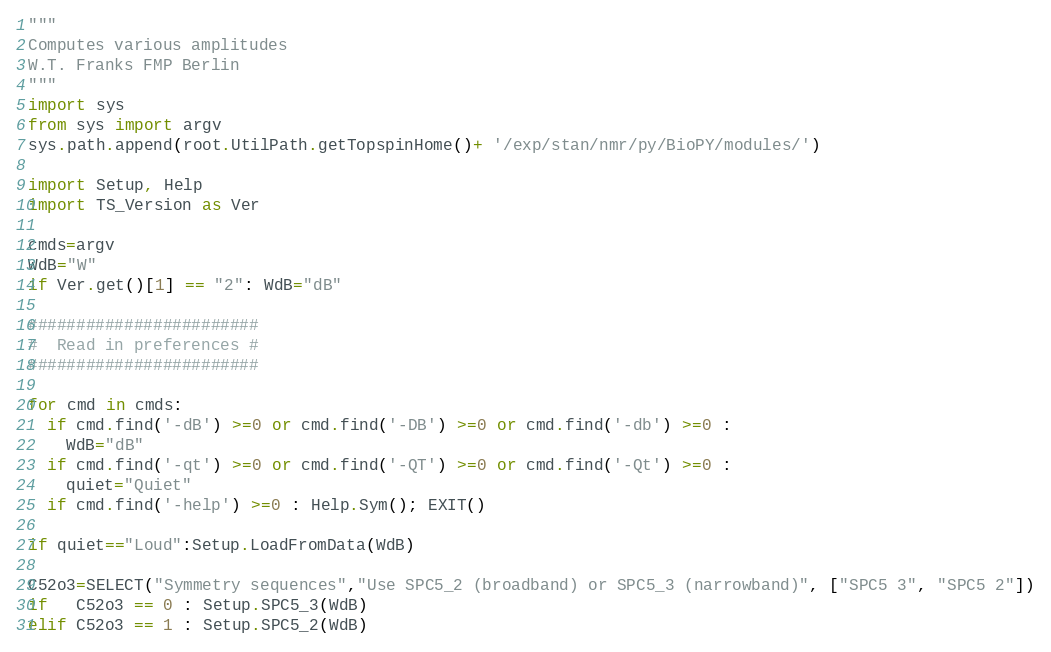<code> <loc_0><loc_0><loc_500><loc_500><_Python_>"""
Computes various amplitudes
W.T. Franks FMP Berlin
"""
import sys
from sys import argv
sys.path.append(root.UtilPath.getTopspinHome()+ '/exp/stan/nmr/py/BioPY/modules/')

import Setup, Help
import TS_Version as Ver

cmds=argv
WdB="W"
if Ver.get()[1] == "2": WdB="dB"

########################
#  Read in preferences #
########################

for cmd in cmds:
  if cmd.find('-dB') >=0 or cmd.find('-DB') >=0 or cmd.find('-db') >=0 :
    WdB="dB"
  if cmd.find('-qt') >=0 or cmd.find('-QT') >=0 or cmd.find('-Qt') >=0 :
    quiet="Quiet"
  if cmd.find('-help') >=0 : Help.Sym(); EXIT()

if quiet=="Loud":Setup.LoadFromData(WdB)

C52o3=SELECT("Symmetry sequences","Use SPC5_2 (broadband) or SPC5_3 (narrowband)", ["SPC5 3", "SPC5 2"])
if   C52o3 == 0 : Setup.SPC5_3(WdB)
elif C52o3 == 1 : Setup.SPC5_2(WdB)
</code> 